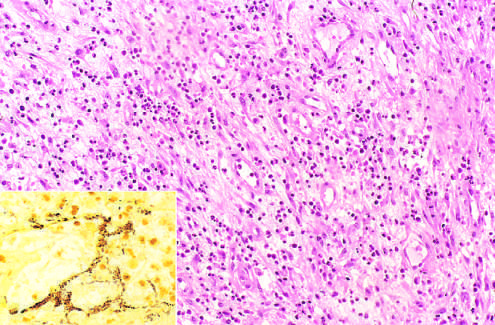re histologic features those of acute inflammation and capillary proliferation?
Answer the question using a single word or phrase. Yes 